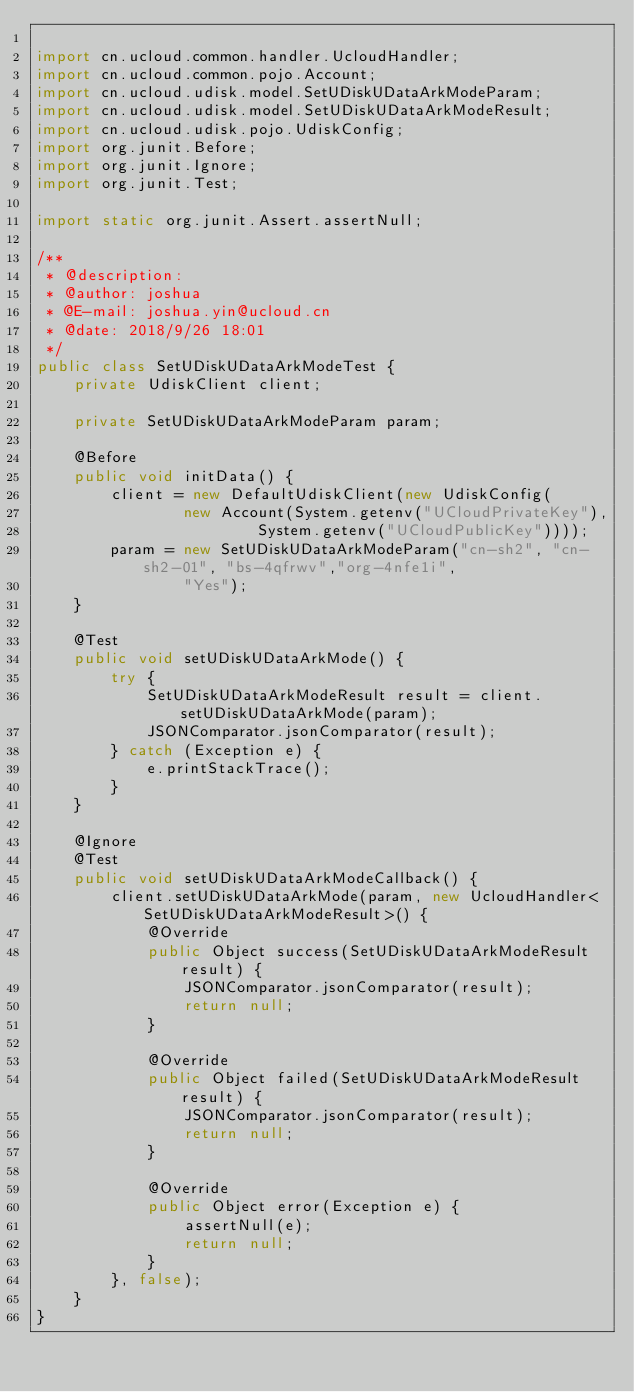<code> <loc_0><loc_0><loc_500><loc_500><_Java_>
import cn.ucloud.common.handler.UcloudHandler;
import cn.ucloud.common.pojo.Account;
import cn.ucloud.udisk.model.SetUDiskUDataArkModeParam;
import cn.ucloud.udisk.model.SetUDiskUDataArkModeResult;
import cn.ucloud.udisk.pojo.UdiskConfig;
import org.junit.Before;
import org.junit.Ignore;
import org.junit.Test;

import static org.junit.Assert.assertNull;

/**
 * @description:
 * @author: joshua
 * @E-mail: joshua.yin@ucloud.cn
 * @date: 2018/9/26 18:01
 */
public class SetUDiskUDataArkModeTest {
    private UdiskClient client;

    private SetUDiskUDataArkModeParam param;

    @Before
    public void initData() {
        client = new DefaultUdiskClient(new UdiskConfig(
                new Account(System.getenv("UCloudPrivateKey"),
                        System.getenv("UCloudPublicKey"))));
        param = new SetUDiskUDataArkModeParam("cn-sh2", "cn-sh2-01", "bs-4qfrwv","org-4nfe1i",
                "Yes");
    }

    @Test
    public void setUDiskUDataArkMode() {
        try {
            SetUDiskUDataArkModeResult result = client.setUDiskUDataArkMode(param);
            JSONComparator.jsonComparator(result);
        } catch (Exception e) {
            e.printStackTrace();
        }
    }

    @Ignore
    @Test
    public void setUDiskUDataArkModeCallback() {
        client.setUDiskUDataArkMode(param, new UcloudHandler<SetUDiskUDataArkModeResult>() {
            @Override
            public Object success(SetUDiskUDataArkModeResult result) {
                JSONComparator.jsonComparator(result);
                return null;
            }

            @Override
            public Object failed(SetUDiskUDataArkModeResult result) {
                JSONComparator.jsonComparator(result);
                return null;
            }

            @Override
            public Object error(Exception e) {
                assertNull(e);
                return null;
            }
        }, false);
    }
}
</code> 